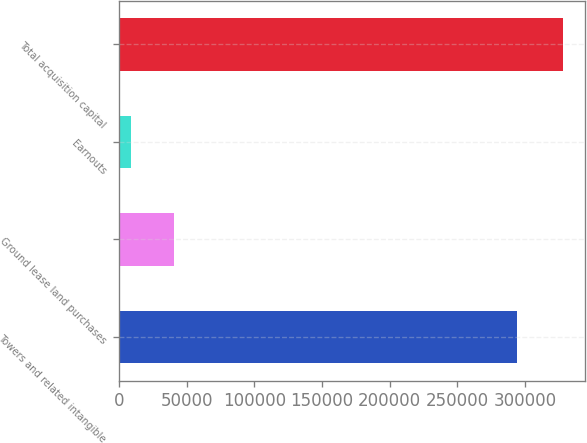Convert chart. <chart><loc_0><loc_0><loc_500><loc_500><bar_chart><fcel>Towers and related intangible<fcel>Ground lease land purchases<fcel>Earnouts<fcel>Total acquisition capital<nl><fcel>294426<fcel>40606.6<fcel>8669<fcel>328045<nl></chart> 